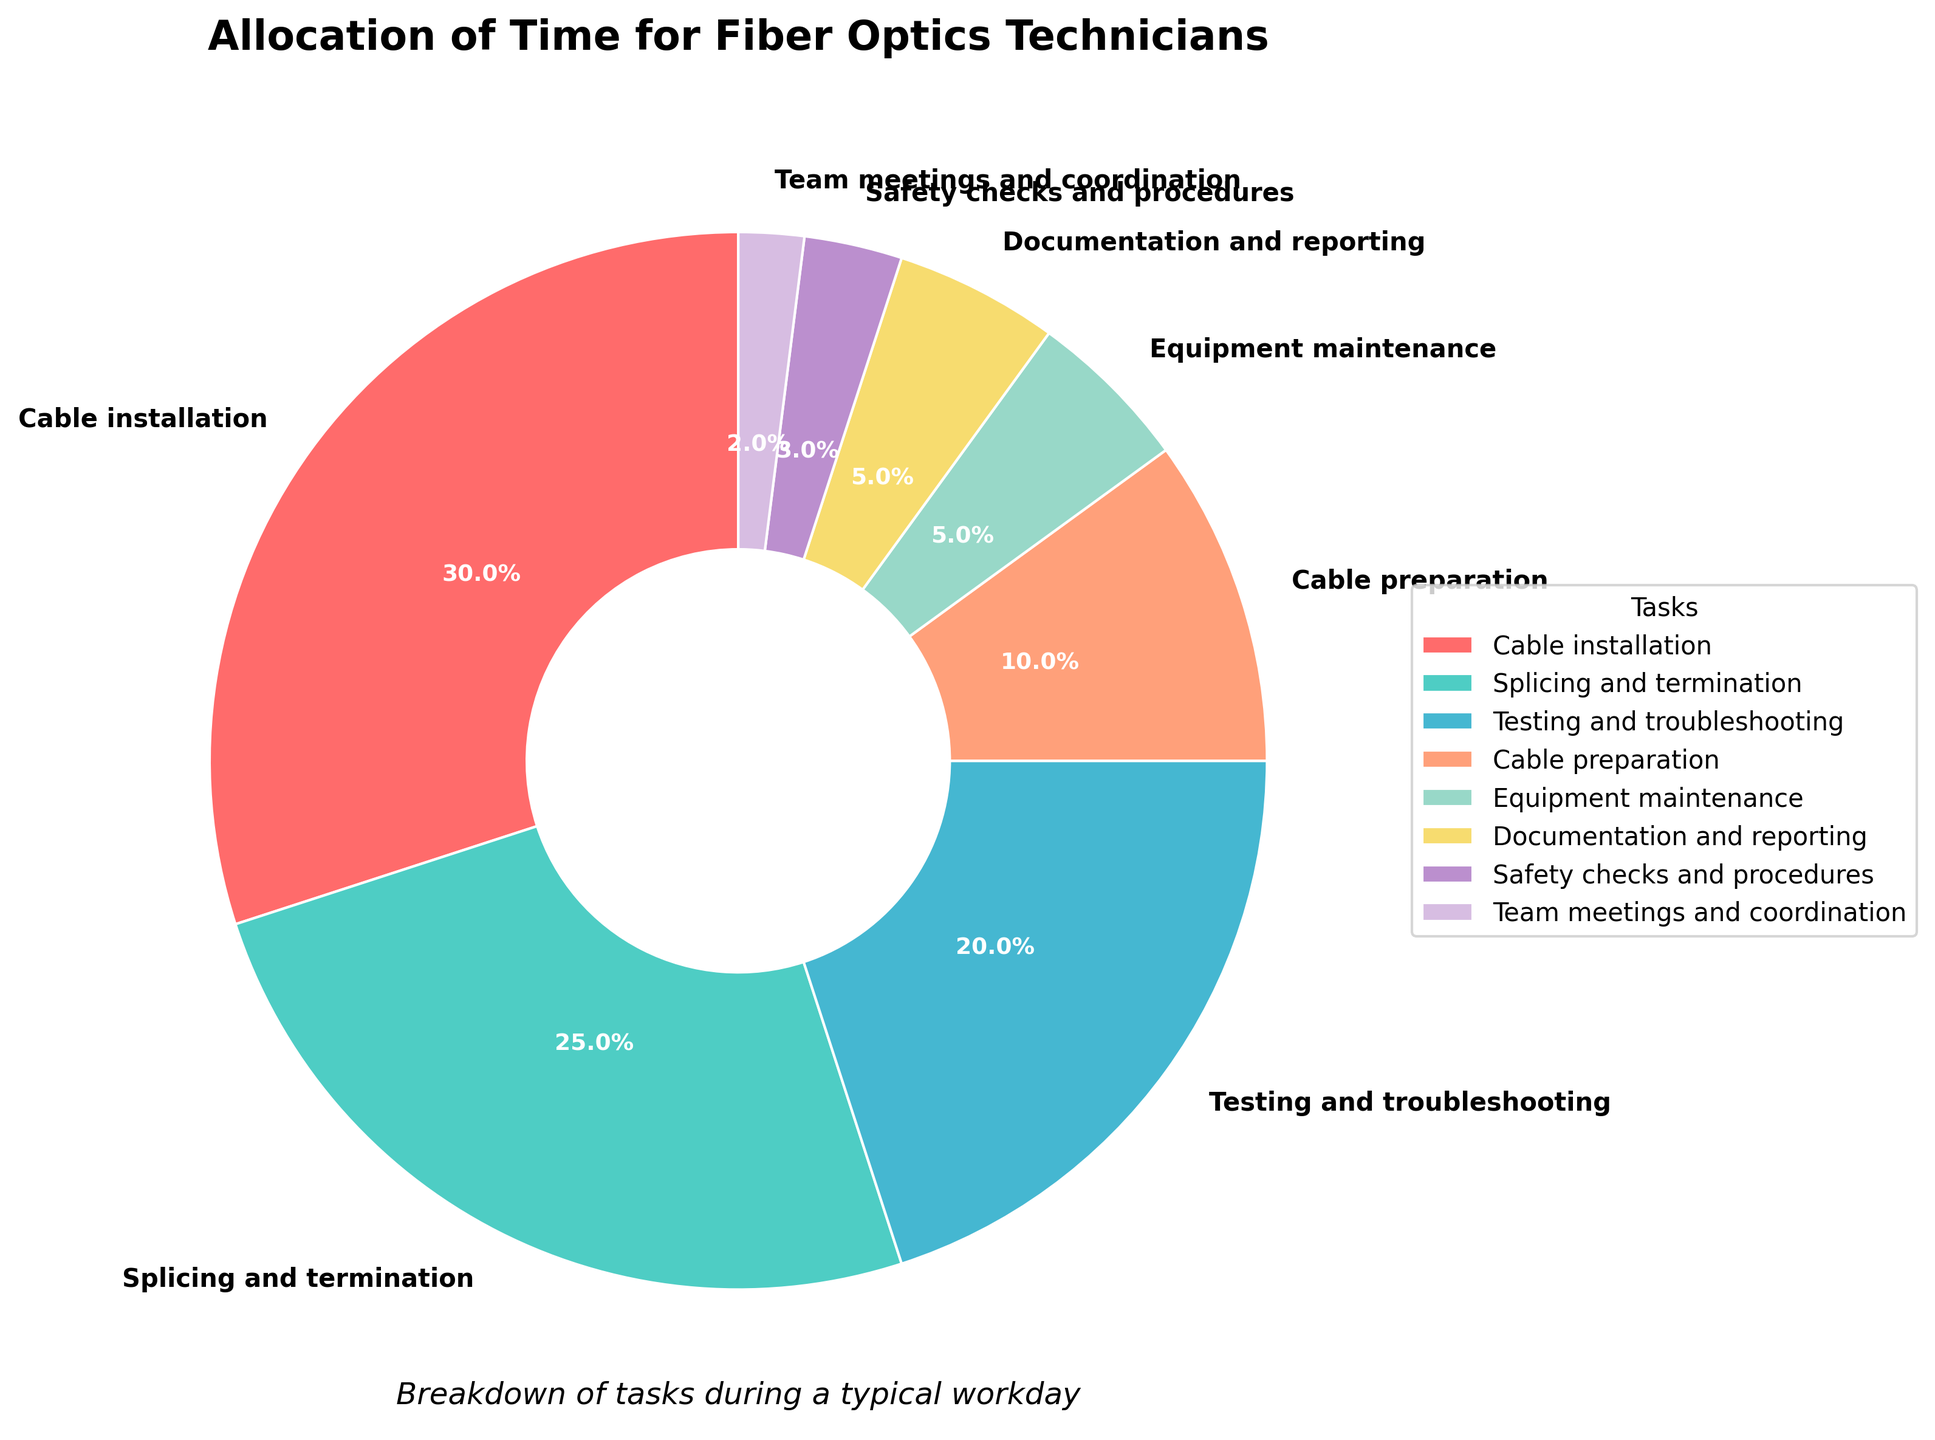Which task occupies the most time during a typical workday for fiber optics technicians? The largest segment in the pie chart represents the task that occupies the most time. The labeled percentages indicate that "Cable installation" is the largest, occupying 30%.
Answer: Cable installation How much more time is spent on testing and troubleshooting than on safety checks and procedures? Locate the segments for both tasks on the pie chart. Testing and troubleshooting occupy 20%, and safety checks and procedures occupy 3%. Subtract the smaller percentage from the larger: 20% - 3% = 17%.
Answer: 17% What is the combined percentage of time spent on equipment maintenance and documentation and reporting? Find the percentages for both tasks on the pie chart. Equipment maintenance occupies 5%, and documentation and reporting occupy 5%. Adding them gives: 5% + 5% = 10%.
Answer: 10% Which task takes up the least time in the workday? The smallest segment in the pie chart represents the task that occupies the least time. The labeled percentages indicate that "Team meetings and coordination" occupy 2%.
Answer: Team meetings and coordination Are more time allocated to splicing and termination or testing and troubleshooting? Compare the percentages for both tasks. Splicing and termination occupies 25%, and testing and troubleshooting occupies 20%. Therefore, splicing and termination takes up more time.
Answer: Splicing and termination What is the total percentage of time spent on cable-related tasks (cable installation, splicing and termination, and cable preparation)? Add the percentages of these tasks: cable installation (30%), splicing and termination (25%), and cable preparation (10%). Summing them gives: 30% + 25% + 10% = 65%.
Answer: 65% Which task has the second-highest allocation of time? Identify the second-largest segment from the pie chart. After cable installation (30%), the next largest is splicing and termination at 25%.
Answer: Splicing and termination How does the time spent on equipment maintenance compare to documentation and reporting? Both tasks occupy the same portion of the pie chart. Each is labeled with 5%. Therefore, the time spent on both activities is equal.
Answer: Equal What is the difference in time allocation between cable installation and the sum of equipment maintenance and team meetings? Cable installation occupies 30%. Equipment maintenance and team meetings together occupy 5% + 2% = 7%. The difference is 30% - 7% = 23%.
Answer: 23% What color represents testing and troubleshooting in the pie chart? Visually identify the segment representing testing and troubleshooting and its corresponding color. The chart shows this segment in a shade of blue.
Answer: Blue 